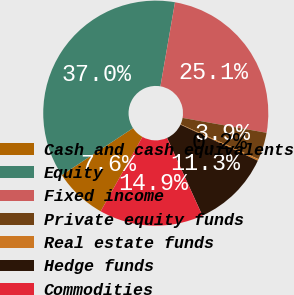Convert chart to OTSL. <chart><loc_0><loc_0><loc_500><loc_500><pie_chart><fcel>Cash and cash equivalents<fcel>Equity<fcel>Fixed income<fcel>Private equity funds<fcel>Real estate funds<fcel>Hedge funds<fcel>Commodities<nl><fcel>7.59%<fcel>37.0%<fcel>25.06%<fcel>3.91%<fcel>0.24%<fcel>11.26%<fcel>14.94%<nl></chart> 